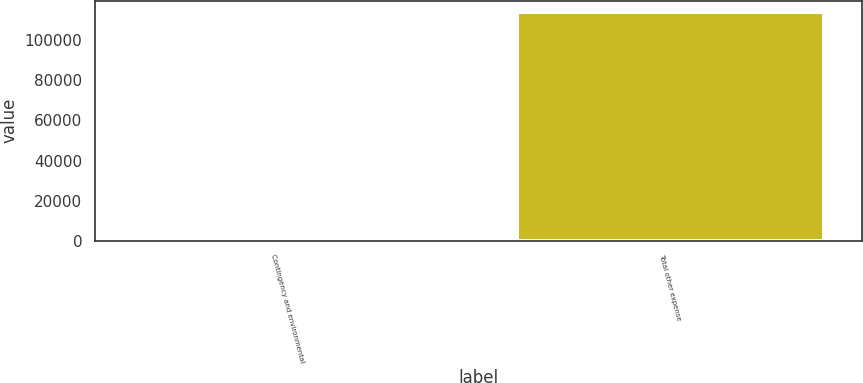Convert chart. <chart><loc_0><loc_0><loc_500><loc_500><bar_chart><fcel>Contingency and environmental<fcel>Total other expense<nl><fcel>478<fcel>114175<nl></chart> 